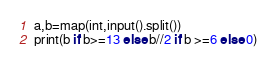<code> <loc_0><loc_0><loc_500><loc_500><_Python_>a,b=map(int,input().split())
print(b if b>=13 else b//2 if b >=6 else 0)</code> 